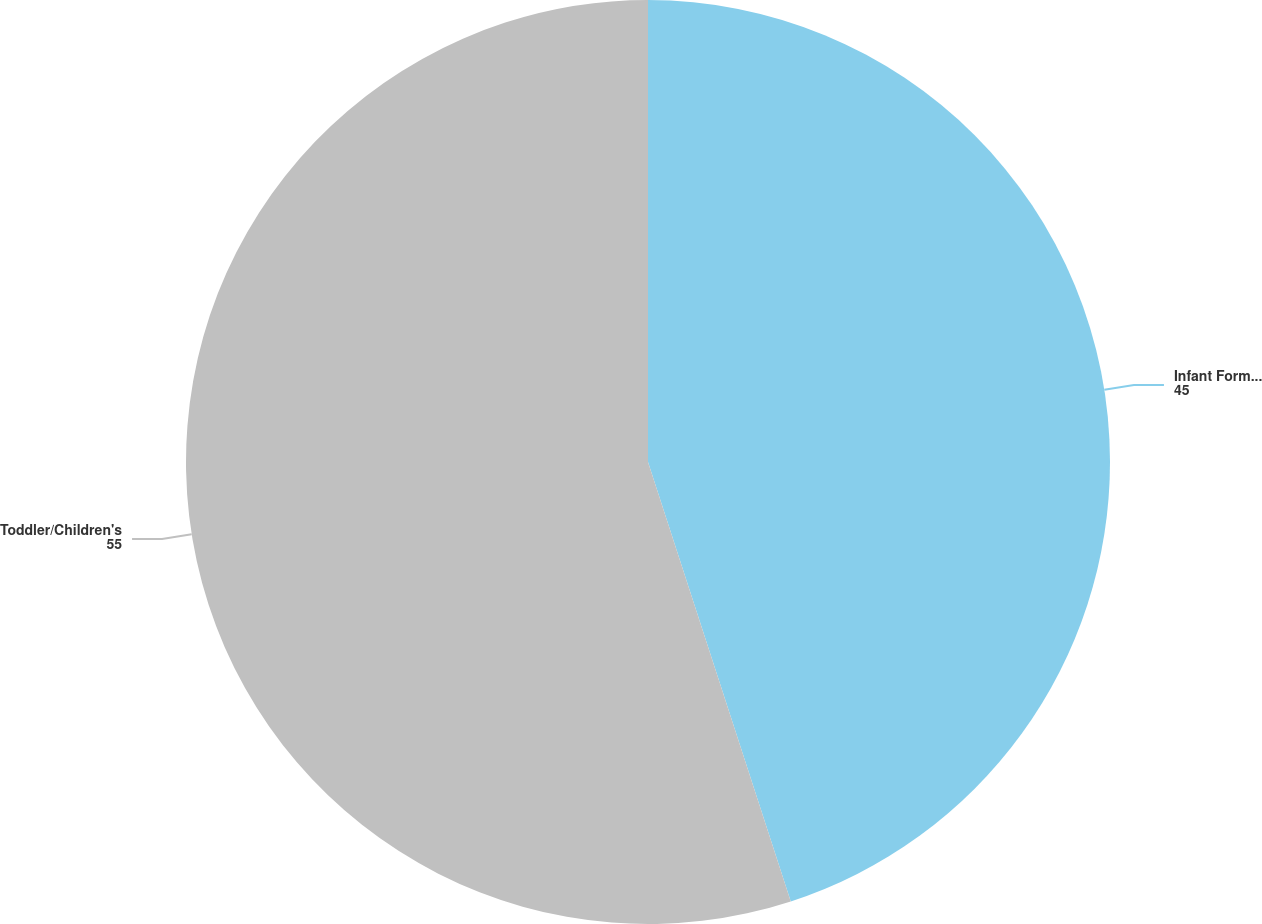<chart> <loc_0><loc_0><loc_500><loc_500><pie_chart><fcel>Infant Formulas<fcel>Toddler/Children's<nl><fcel>45.0%<fcel>55.0%<nl></chart> 